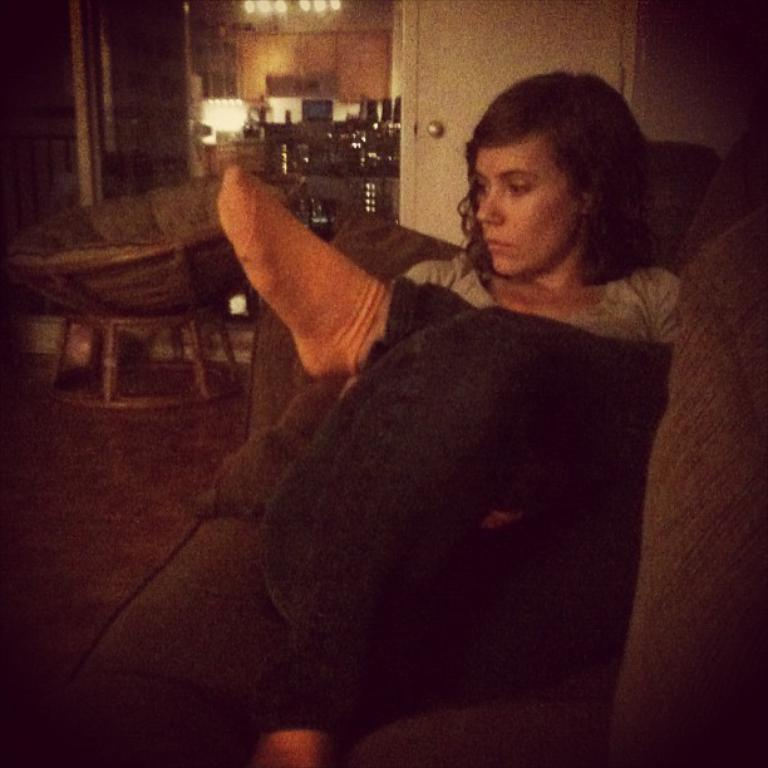What is the woman in the image doing? The woman is sitting on a sofa in the image. What can be seen in the background of the image? There is a door in the image. What is providing illumination in the image? There is a light in the image. Can you tell me how many goldfish are swimming in the bowl on the table in the image? There is no goldfish or bowl present in the image; it only features a woman sitting on a sofa, a door, and a light. 